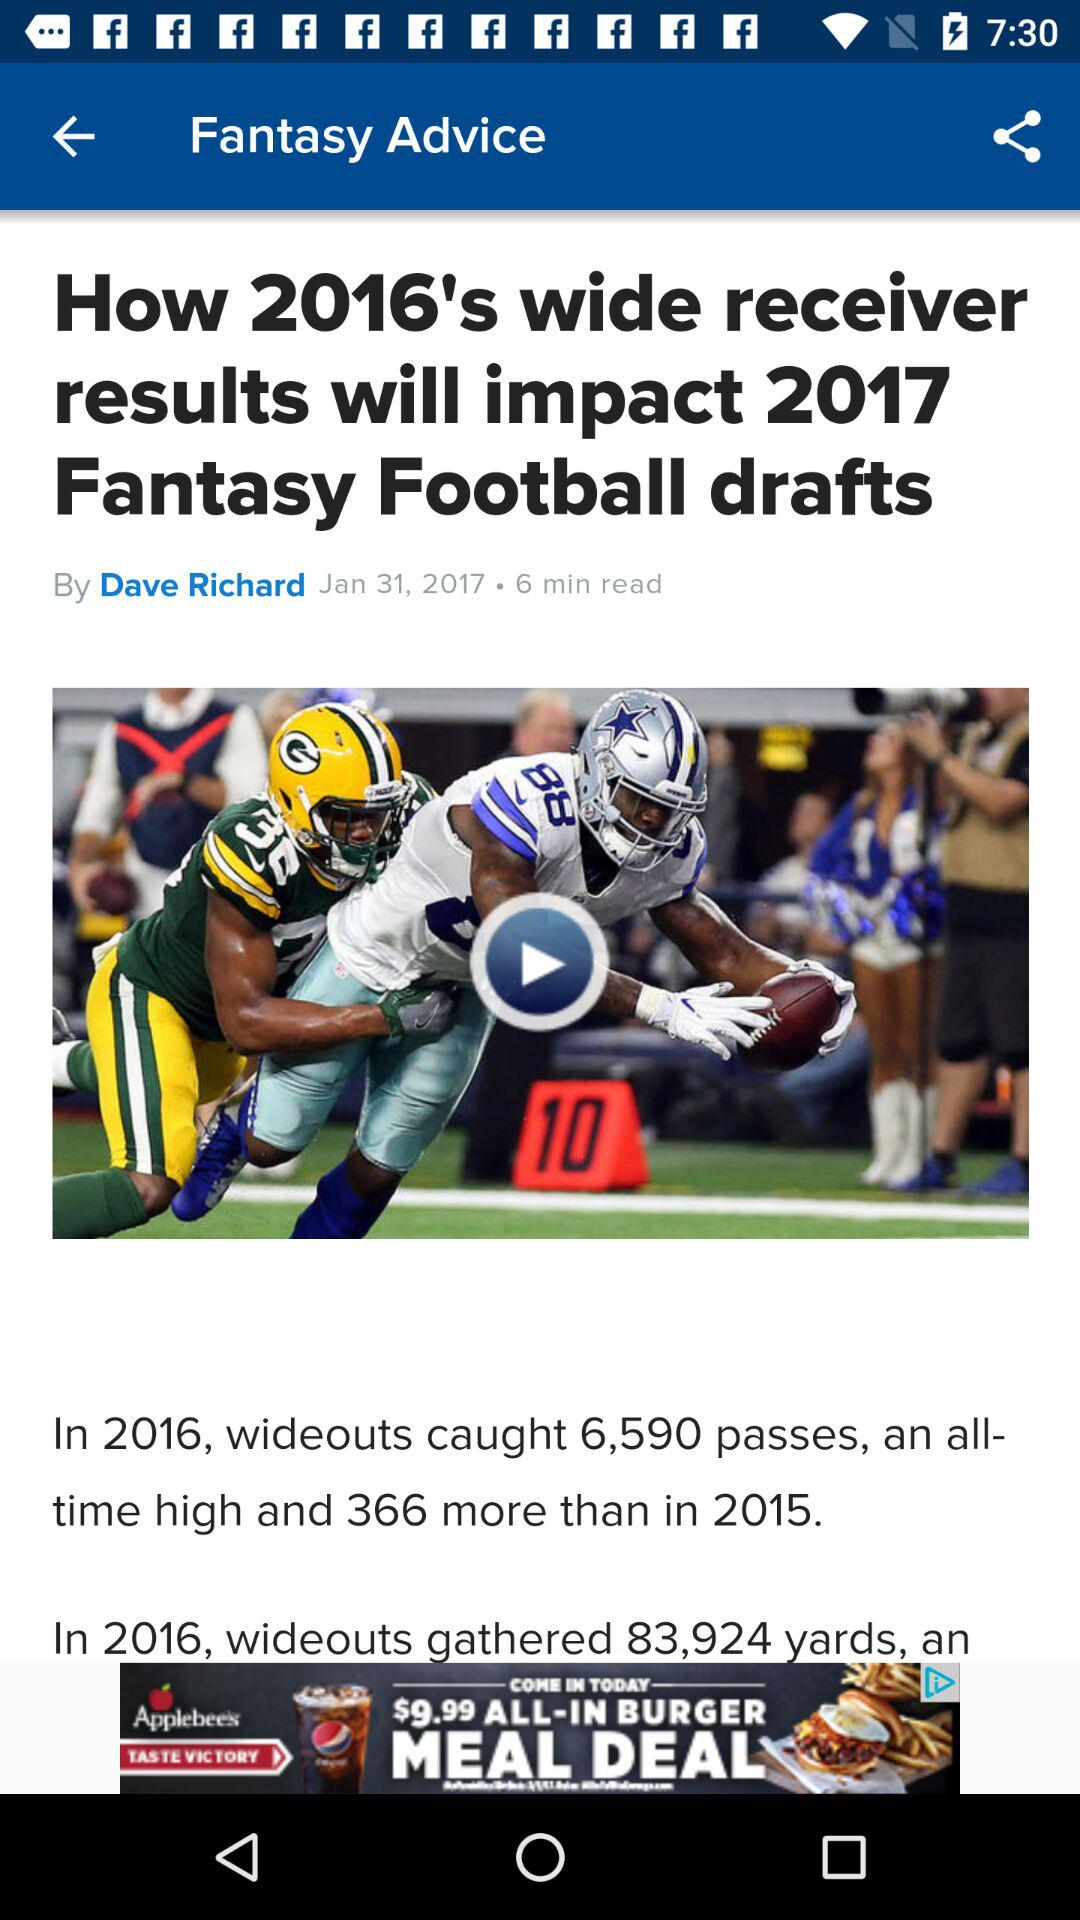How many more passes did wideouts catch in 2016 than in 2015? 366 